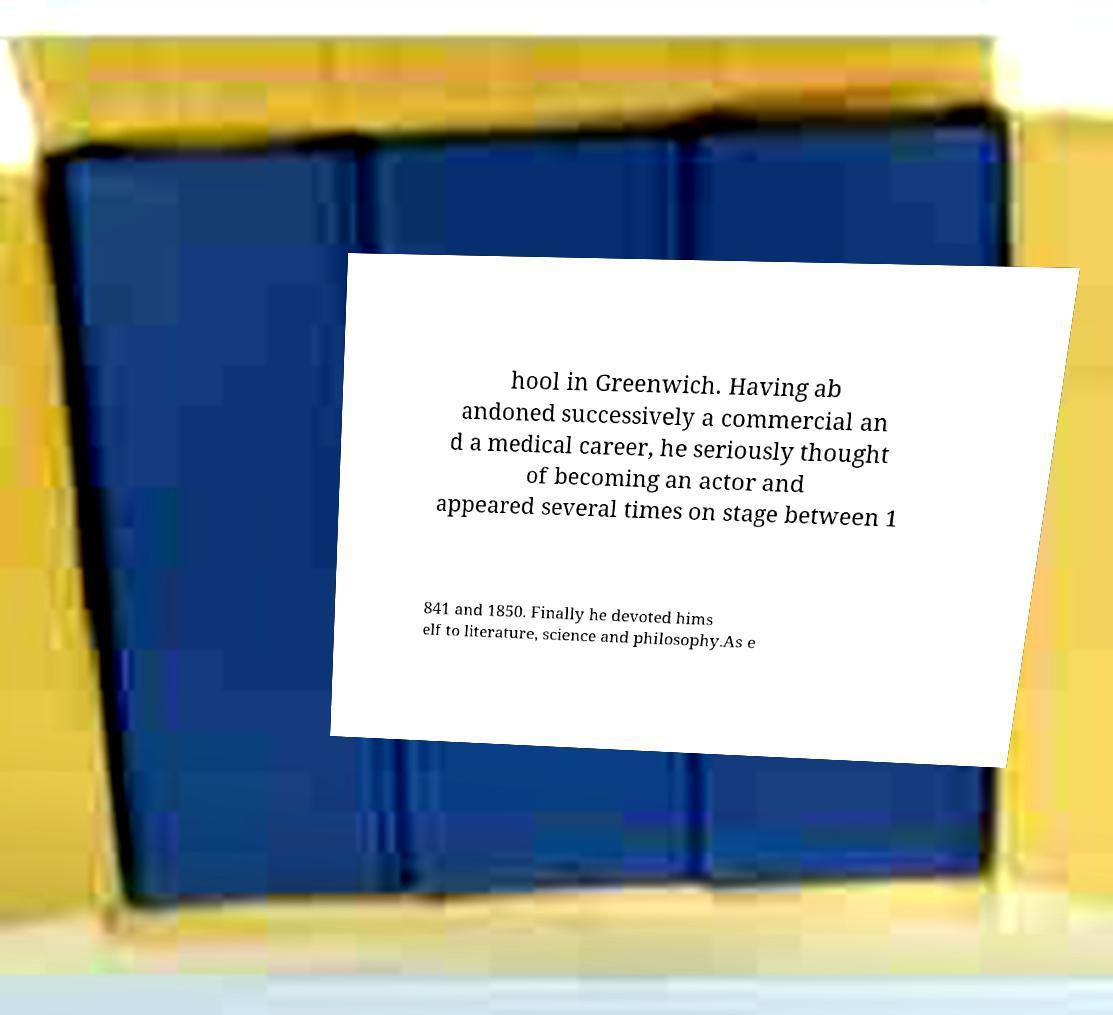What messages or text are displayed in this image? I need them in a readable, typed format. hool in Greenwich. Having ab andoned successively a commercial an d a medical career, he seriously thought of becoming an actor and appeared several times on stage between 1 841 and 1850. Finally he devoted hims elf to literature, science and philosophy.As e 